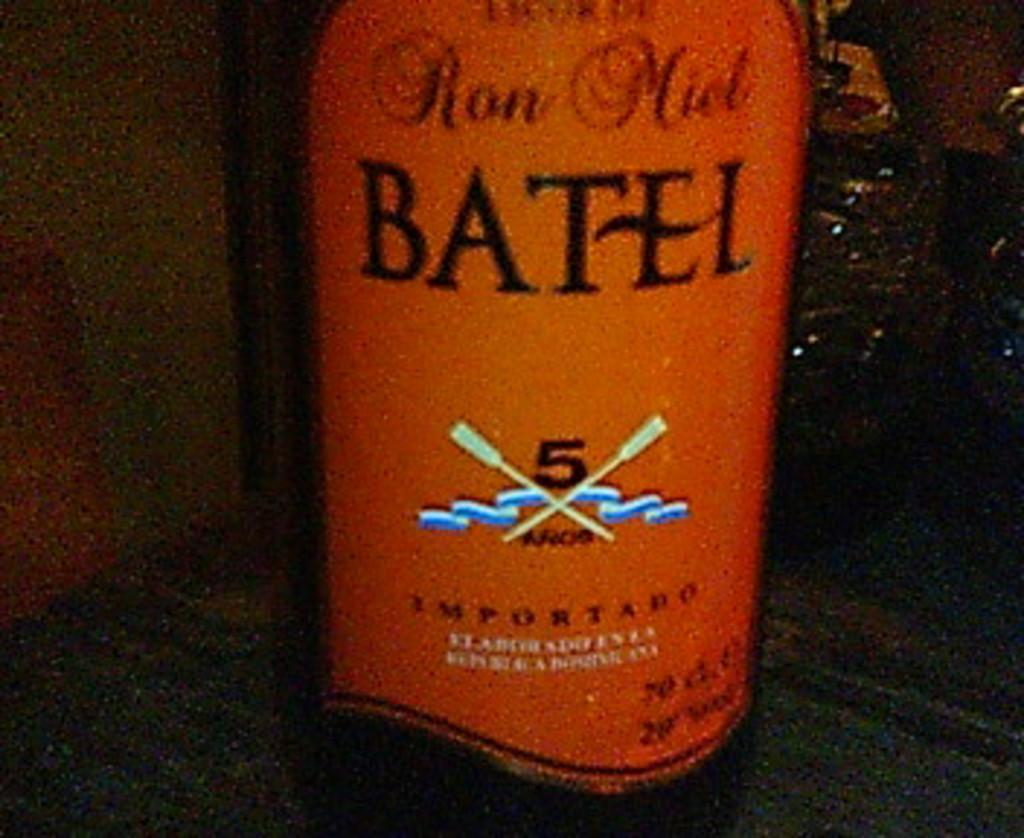Provide a one-sentence caption for the provided image. An orange bottle of  Ron Miel Batel 5. 